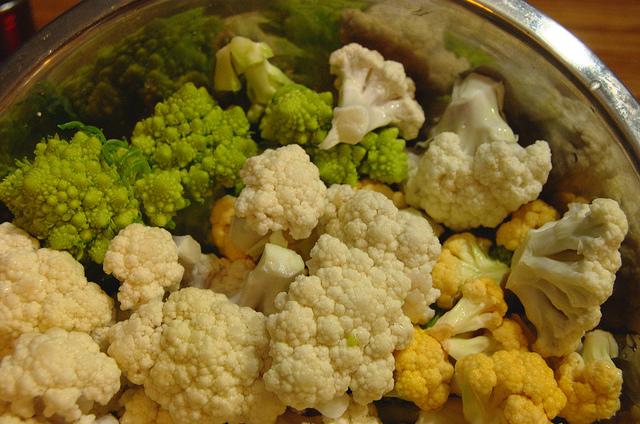How many pieces of cauliflower are in this pan?
Concise answer only. 10. What three colors are the vegetables in the pan?
Quick response, please. Green, white and yellow. What color is the pot?
Answer briefly. Silver. 